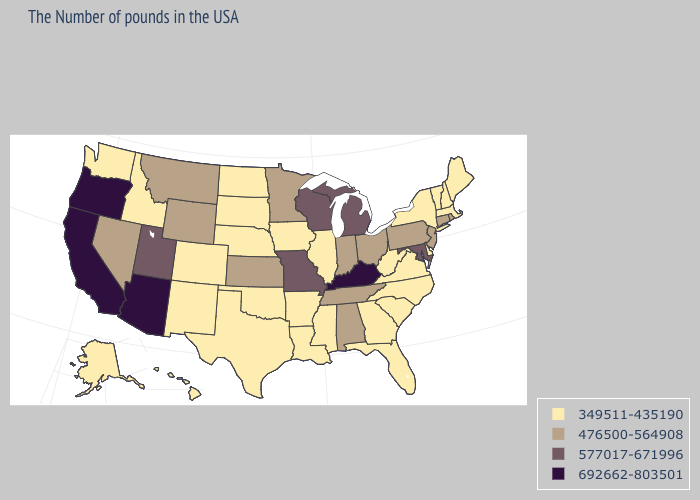What is the highest value in states that border Indiana?
Write a very short answer. 692662-803501. Name the states that have a value in the range 349511-435190?
Be succinct. Maine, Massachusetts, New Hampshire, Vermont, New York, Delaware, Virginia, North Carolina, South Carolina, West Virginia, Florida, Georgia, Illinois, Mississippi, Louisiana, Arkansas, Iowa, Nebraska, Oklahoma, Texas, South Dakota, North Dakota, Colorado, New Mexico, Idaho, Washington, Alaska, Hawaii. What is the value of Florida?
Quick response, please. 349511-435190. What is the highest value in states that border Utah?
Be succinct. 692662-803501. Does the first symbol in the legend represent the smallest category?
Concise answer only. Yes. What is the highest value in states that border Wisconsin?
Give a very brief answer. 577017-671996. Does California have the highest value in the USA?
Quick response, please. Yes. Which states hav the highest value in the South?
Be succinct. Kentucky. What is the value of Hawaii?
Concise answer only. 349511-435190. What is the lowest value in the South?
Quick response, please. 349511-435190. Name the states that have a value in the range 692662-803501?
Concise answer only. Kentucky, Arizona, California, Oregon. Among the states that border Michigan , which have the highest value?
Concise answer only. Wisconsin. What is the value of Ohio?
Write a very short answer. 476500-564908. Does the map have missing data?
Give a very brief answer. No. Does Kentucky have the highest value in the USA?
Keep it brief. Yes. 